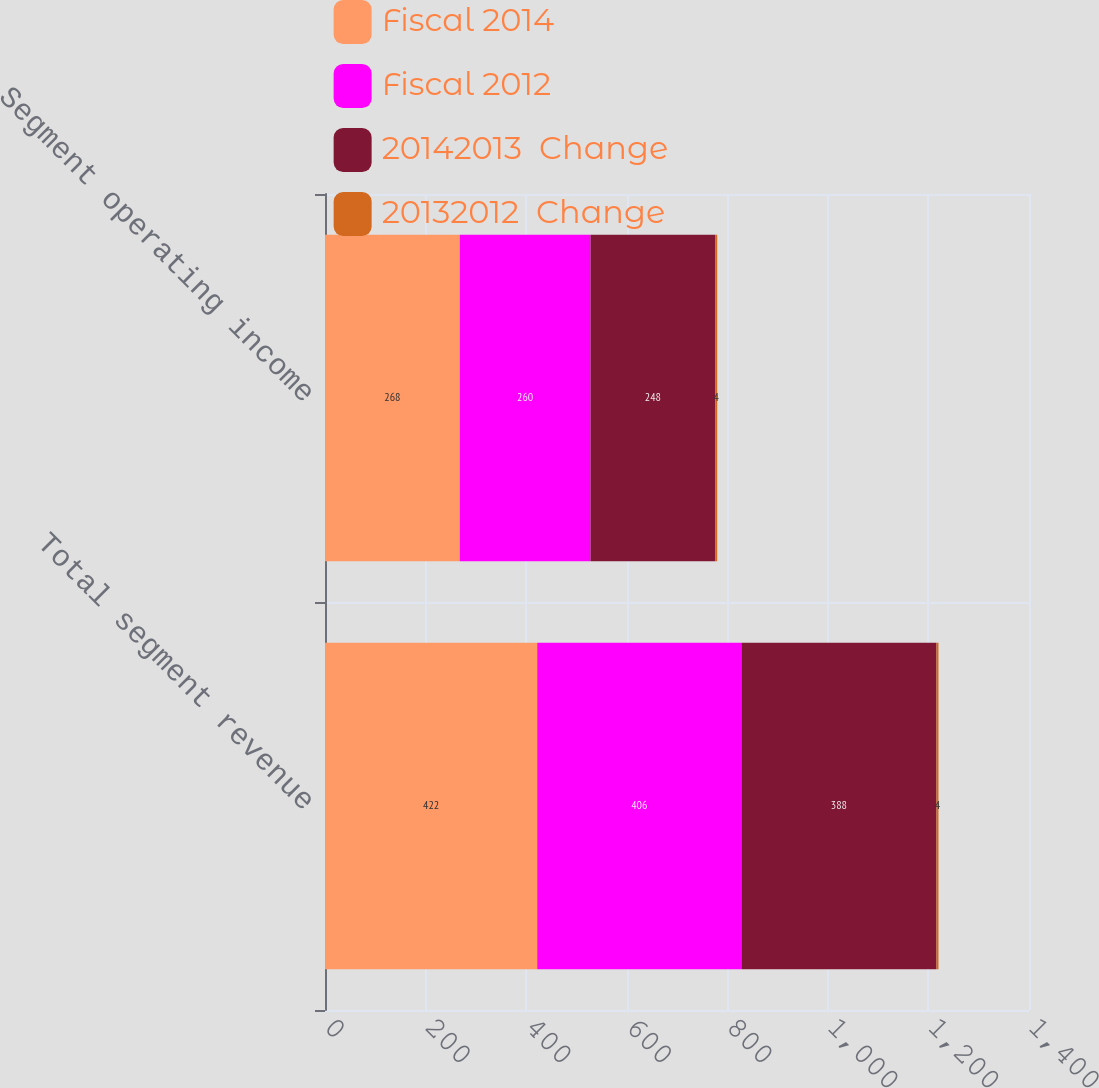Convert chart to OTSL. <chart><loc_0><loc_0><loc_500><loc_500><stacked_bar_chart><ecel><fcel>Total segment revenue<fcel>Segment operating income<nl><fcel>Fiscal 2014<fcel>422<fcel>268<nl><fcel>Fiscal 2012<fcel>406<fcel>260<nl><fcel>20142013  Change<fcel>388<fcel>248<nl><fcel>20132012  Change<fcel>4<fcel>4<nl></chart> 